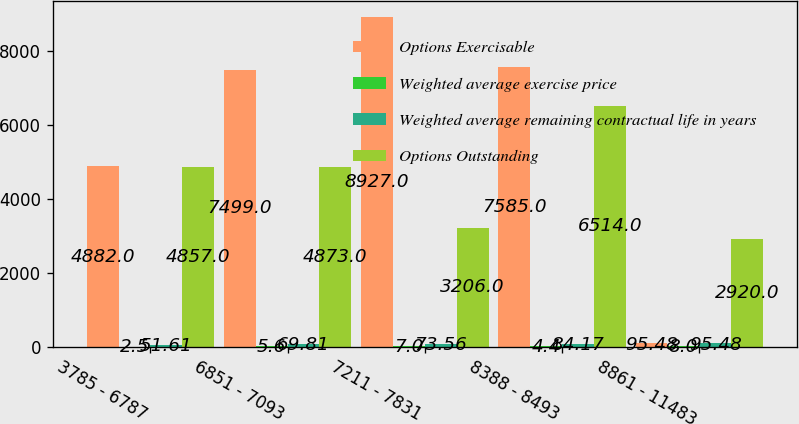Convert chart. <chart><loc_0><loc_0><loc_500><loc_500><stacked_bar_chart><ecel><fcel>3785 - 6787<fcel>6851 - 7093<fcel>7211 - 7831<fcel>8388 - 8493<fcel>8861 - 11483<nl><fcel>Options Exercisable<fcel>4882<fcel>7499<fcel>8927<fcel>7585<fcel>95.48<nl><fcel>Weighted average exercise price<fcel>2.5<fcel>5.6<fcel>7<fcel>4.4<fcel>8<nl><fcel>Weighted average remaining contractual life in years<fcel>51.61<fcel>69.81<fcel>73.56<fcel>84.17<fcel>95.48<nl><fcel>Options Outstanding<fcel>4857<fcel>4873<fcel>3206<fcel>6514<fcel>2920<nl></chart> 